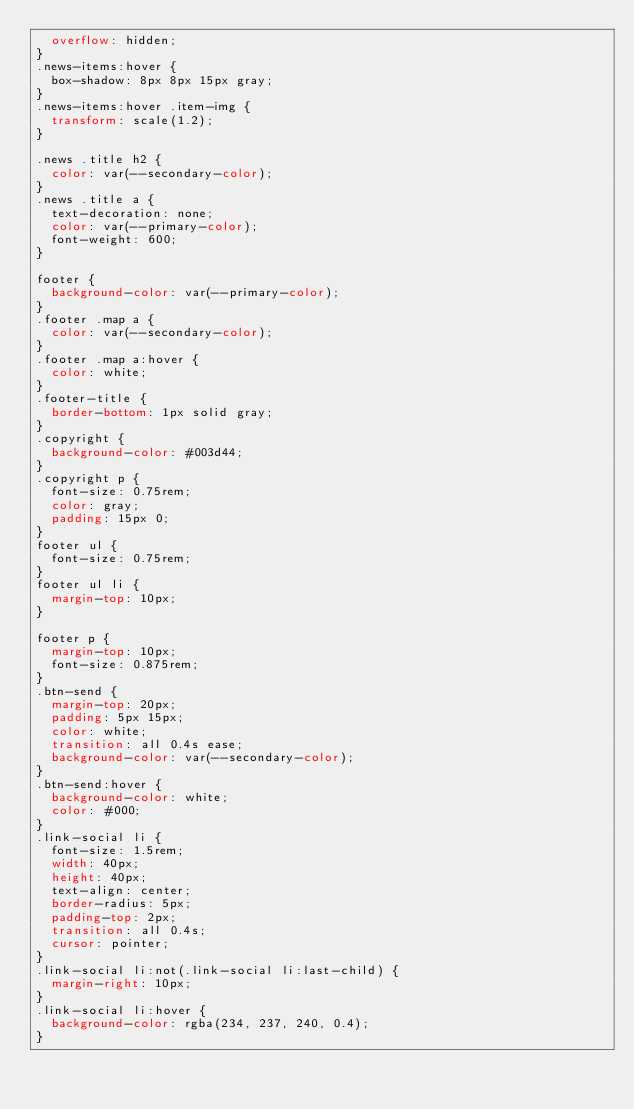Convert code to text. <code><loc_0><loc_0><loc_500><loc_500><_CSS_>  overflow: hidden;
}
.news-items:hover {
  box-shadow: 8px 8px 15px gray;
}
.news-items:hover .item-img {
  transform: scale(1.2);
}

.news .title h2 {
  color: var(--secondary-color);
}
.news .title a {
  text-decoration: none;
  color: var(--primary-color);
  font-weight: 600;
}

footer {
  background-color: var(--primary-color);
}
.footer .map a {
  color: var(--secondary-color);
}
.footer .map a:hover {
  color: white;
}
.footer-title {
  border-bottom: 1px solid gray;
}
.copyright {
  background-color: #003d44;
}
.copyright p {
  font-size: 0.75rem;
  color: gray;
  padding: 15px 0;
}
footer ul {
  font-size: 0.75rem;
}
footer ul li {
  margin-top: 10px;
}

footer p {
  margin-top: 10px;
  font-size: 0.875rem;
}
.btn-send {
  margin-top: 20px;
  padding: 5px 15px;
  color: white;
  transition: all 0.4s ease;
  background-color: var(--secondary-color);
}
.btn-send:hover {
  background-color: white;
  color: #000;
}
.link-social li {
  font-size: 1.5rem;
  width: 40px;
  height: 40px;
  text-align: center;
  border-radius: 5px;
  padding-top: 2px;
  transition: all 0.4s;
  cursor: pointer;
}
.link-social li:not(.link-social li:last-child) {
  margin-right: 10px;
}
.link-social li:hover {
  background-color: rgba(234, 237, 240, 0.4);
}
</code> 